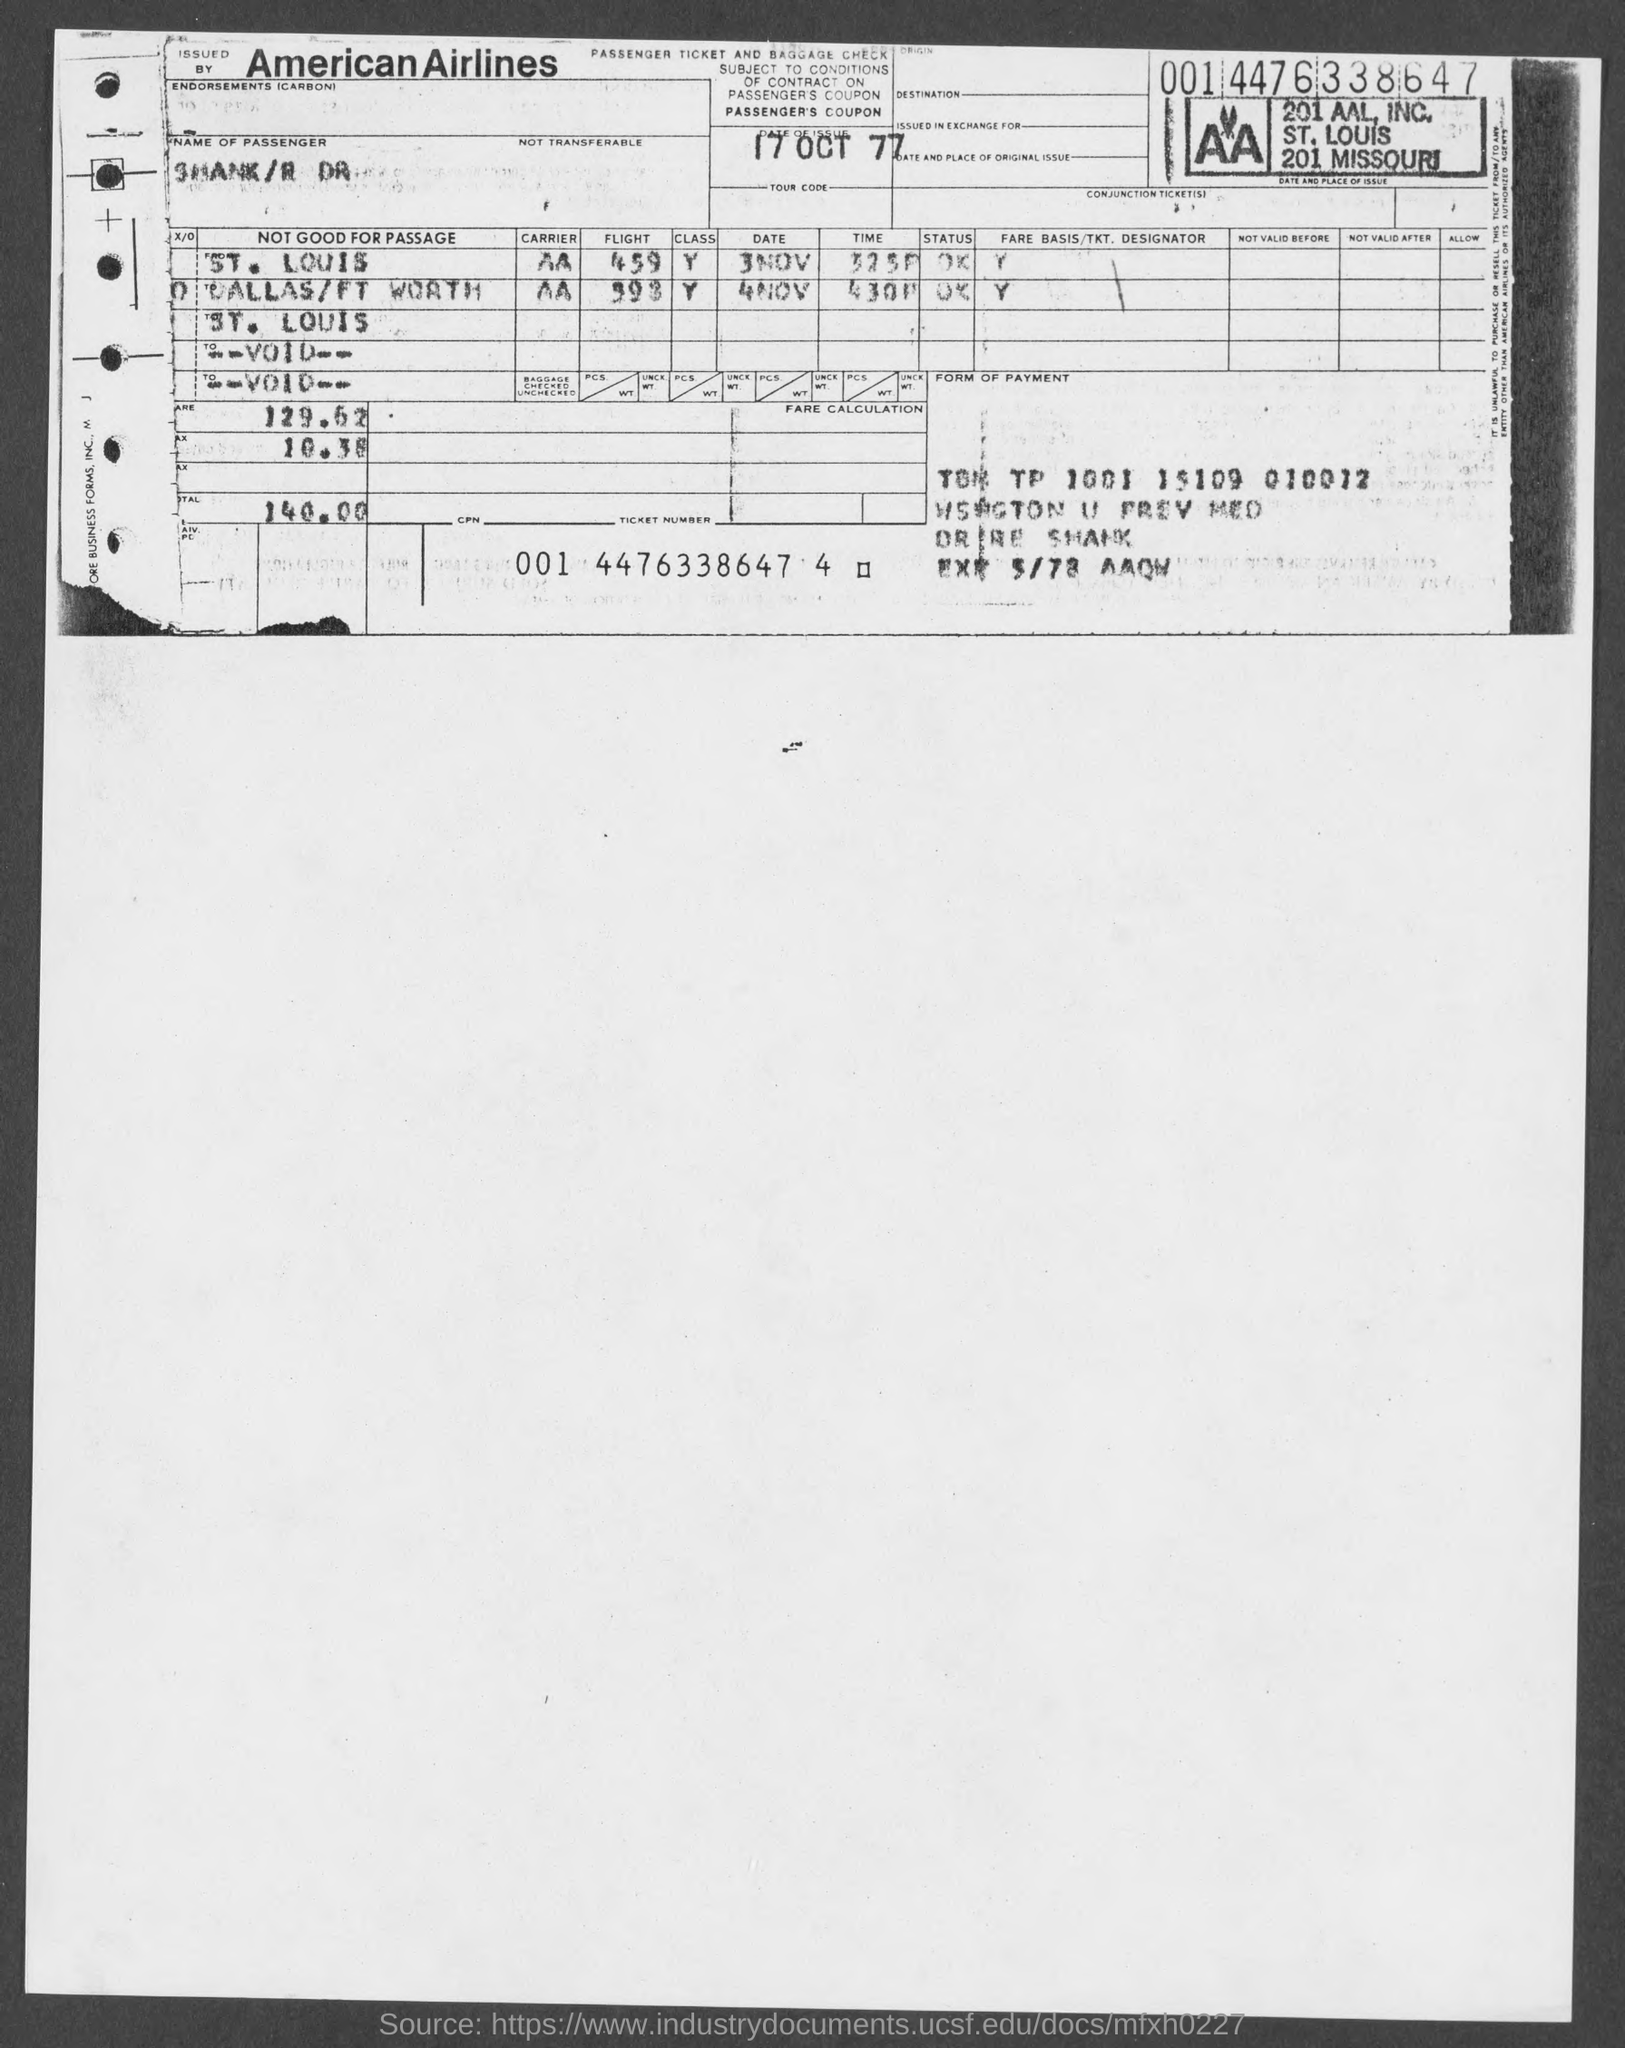Which Airlines ticket is provided?
Keep it short and to the point. American. Which is the date of issue?
Ensure brevity in your answer.  17 OCT 77. 